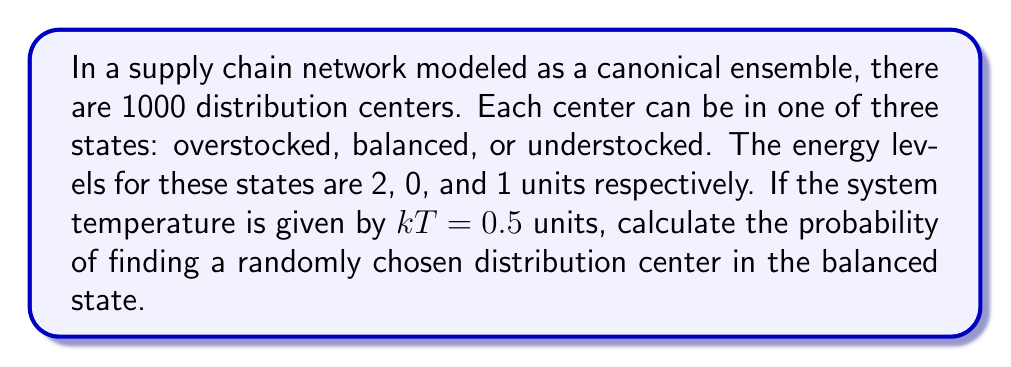Solve this math problem. To solve this problem, we'll use the principles of the canonical ensemble from statistical mechanics:

1. First, recall the probability of a system being in a particular state $i$ with energy $E_i$ is given by:

   $$P_i = \frac{e^{-E_i/kT}}{Z}$$

   where $Z$ is the partition function.

2. The partition function $Z$ is the sum of the Boltzmann factors for all possible states:

   $$Z = \sum_i e^{-E_i/kT}$$

3. In our case, we have three states with energies:
   - Overstocked: $E_1 = 2$
   - Balanced: $E_2 = 0$
   - Understocked: $E_3 = 1$

4. Let's calculate the partition function:

   $$Z = e^{-2/0.5} + e^{-0/0.5} + e^{-1/0.5} = e^{-4} + 1 + e^{-2}$$

5. Now, we can calculate the probability of a distribution center being in the balanced state:

   $$P_{\text{balanced}} = \frac{e^{-0/0.5}}{e^{-4} + 1 + e^{-2}} = \frac{1}{e^{-4} + 1 + e^{-2}}$$

6. Evaluating this numerically:

   $$P_{\text{balanced}} = \frac{1}{0.0183 + 1 + 0.1353} \approx 0.8681$$

Thus, the probability of finding a randomly chosen distribution center in the balanced state is approximately 0.8681 or 86.81%.
Answer: 0.8681 